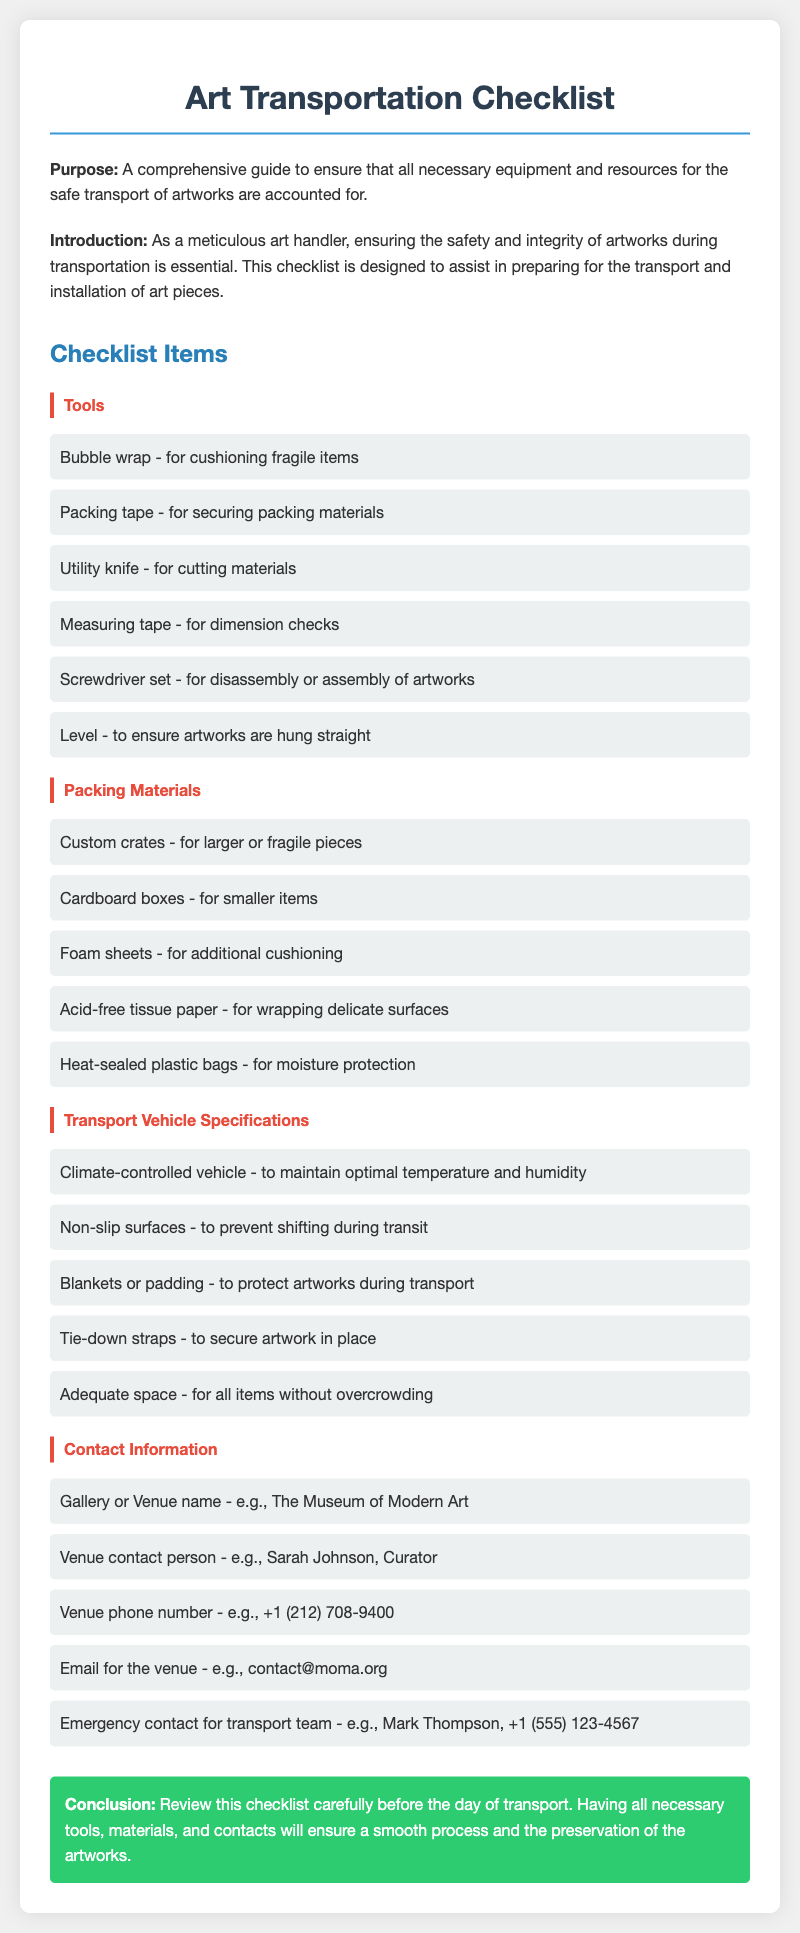what is the purpose of the checklist? The purpose is stated in the introduction section, which is to ensure that all necessary equipment and resources for the safe transport of artworks are accounted for.
Answer: A comprehensive guide to ensure that all necessary equipment and resources for the safe transport of artworks are accounted for how many categories are listed in the checklist? The document lists four main categories: Tools, Packing Materials, Transport Vehicle Specifications, and Contact Information.
Answer: Four what types of packing materials are included? This question requires identifying multiple items listed under the Packing Materials category, which include different materials for wrapping and cushioning.
Answer: Custom crates, Cardboard boxes, Foam sheets, Acid-free tissue paper, Heat-sealed plastic bags which tool is used for dimension checks? The specific tool mentioned for dimension checks is found under the Tools category of the checklist.
Answer: Measuring tape what type of vehicle is recommended for transport? The recommendation for vehicle type is found in the Transport Vehicle Specifications category, where it specifies the ideal climate conditions for the vehicle to maintain.
Answer: Climate-controlled vehicle who should be contacted in an emergency for the transport team? The emergency contact for the transport team is mentioned in the Contact Information section of the checklist.
Answer: Mark Thompson what material is recommended for wrapping delicate surfaces? The material for wrapping delicate surfaces is listed under the Packing Materials category in the document, specifically for protecting artworks during transport.
Answer: Acid-free tissue paper what is the maximum expected temperature in the transport vehicle? This requires reasoning about the necessity of temperature control mentioned in the Transport Vehicle Specifications, though the specific temperature is not provided in the document.
Answer: Not specified 